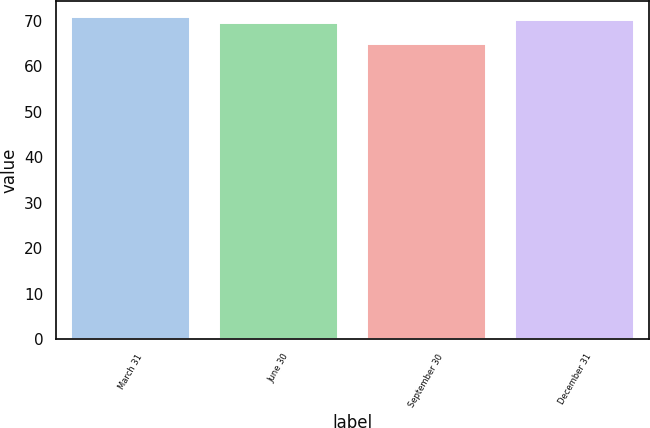Convert chart to OTSL. <chart><loc_0><loc_0><loc_500><loc_500><bar_chart><fcel>March 31<fcel>June 30<fcel>September 30<fcel>December 31<nl><fcel>70.8<fcel>69.45<fcel>64.79<fcel>70.05<nl></chart> 